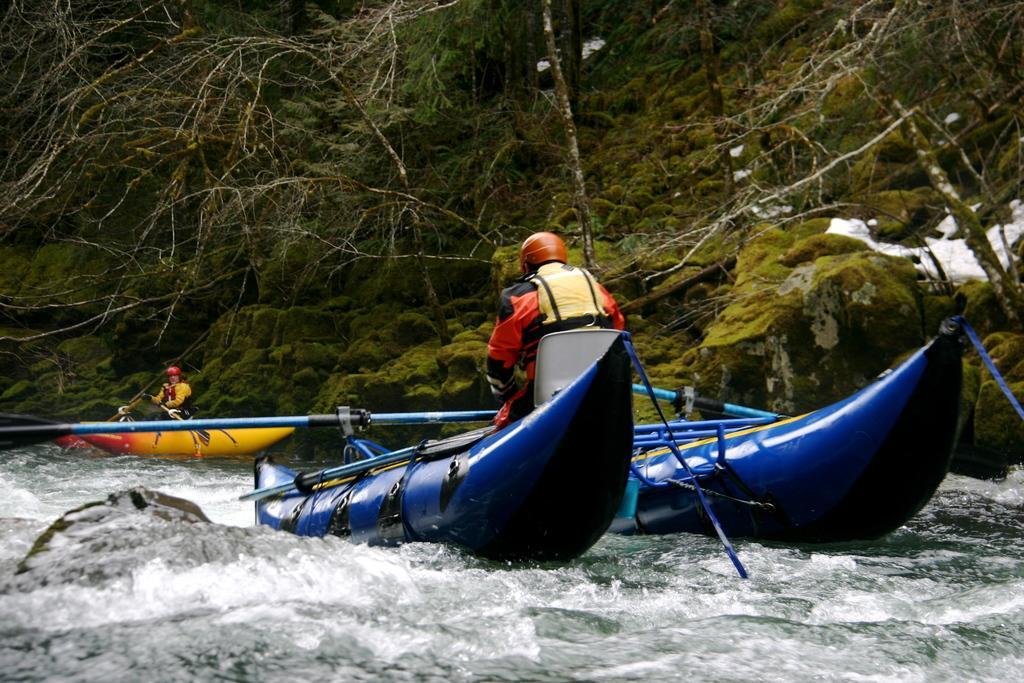Please provide a concise description of this image. In this picture I can see boats on the water, there are two persons sitting on the boats, there are paddles, and in the background there are trees and plants. 